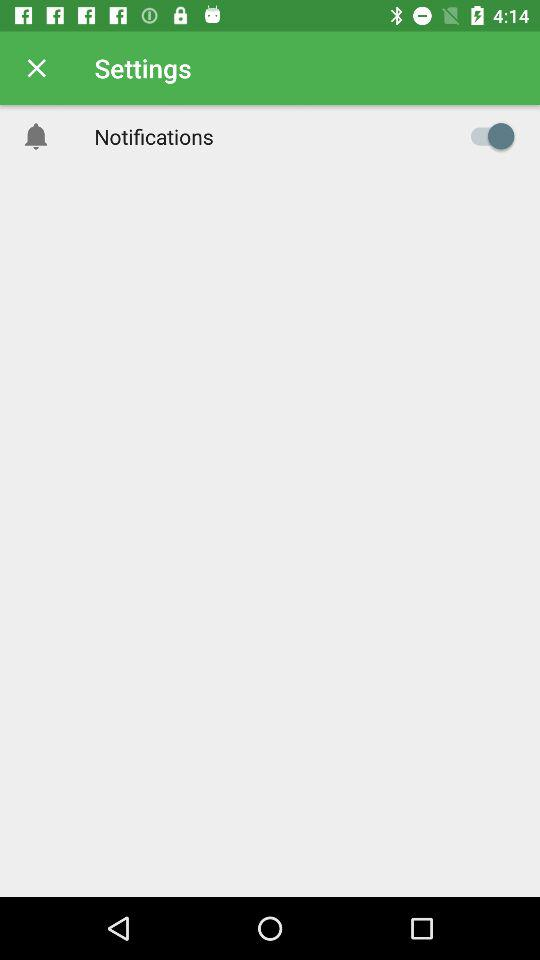What is the status of the notifications setting? The status is "on". 